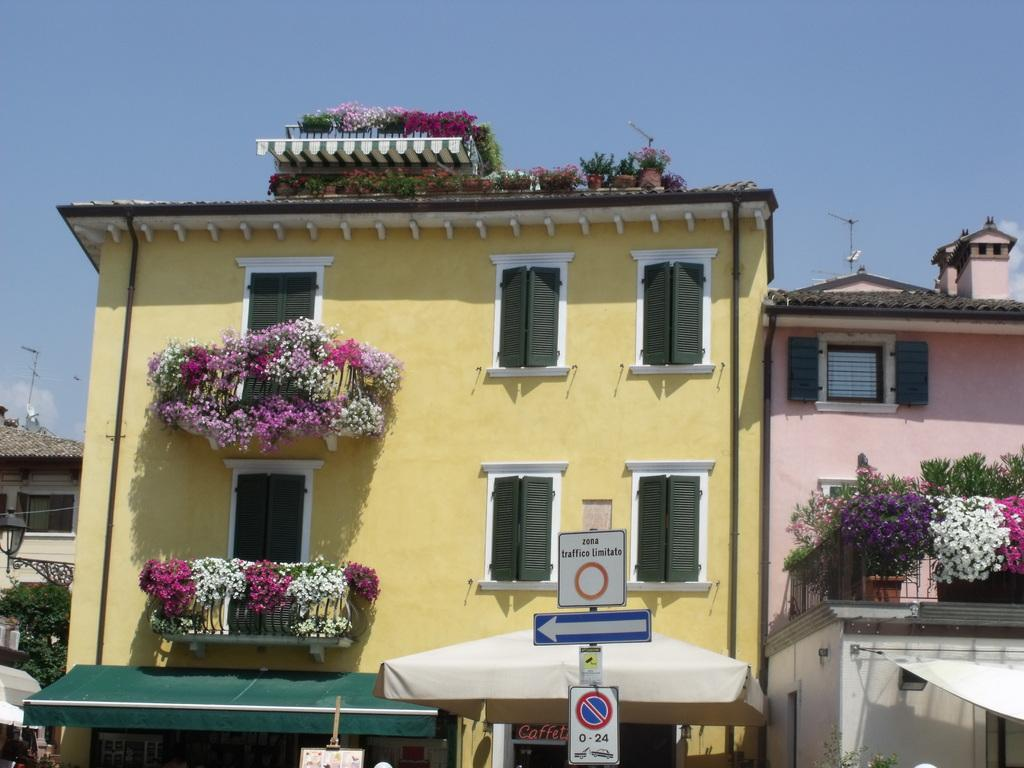What type of structures can be seen in the image? There are buildings in the image. What architectural features are present on the buildings? There are windows and doors visible on the buildings. What type of vegetation is present in the image? There are plants with flowers in the image. What type of enclosures can be seen in the image? There are fences in the image. What type of signage is present in the image? There are boards on a pole in the image. What type of infrastructure is present in the image? There is a light pole and an antenna in the image. What can be seen in the sky in the image? There are clouds in the sky in the image. How many oranges are hanging from the light pole in the image? There are no oranges present in the image. What type of selection process is being conducted in the image? There is no selection process depicted in the image. What type of alarm system is installed on the buildings in the image? There is no mention of an alarm system in the image. 